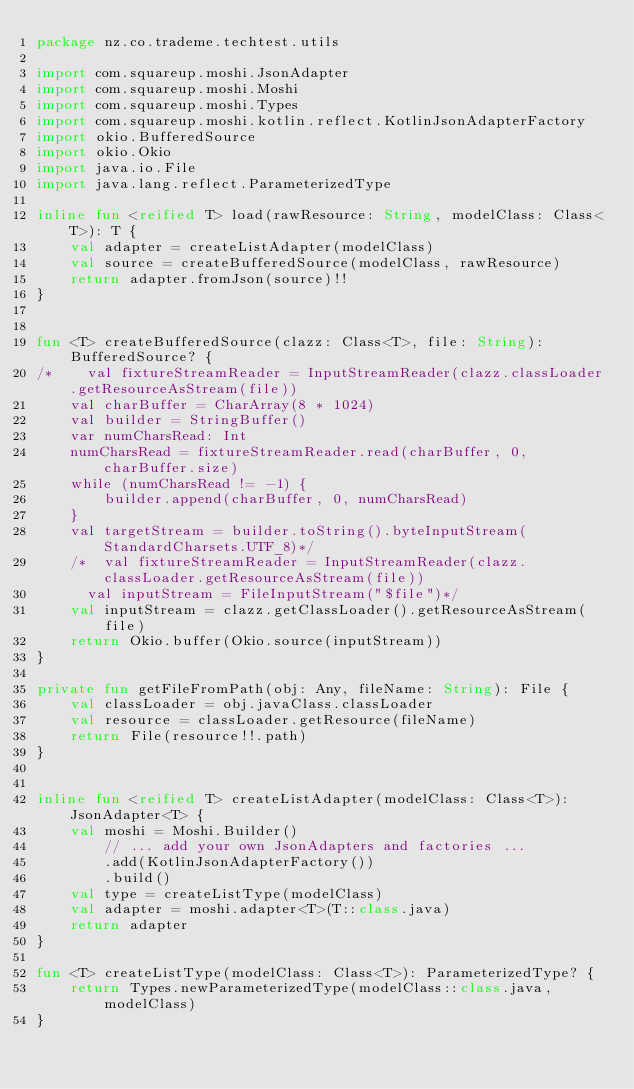Convert code to text. <code><loc_0><loc_0><loc_500><loc_500><_Kotlin_>package nz.co.trademe.techtest.utils

import com.squareup.moshi.JsonAdapter
import com.squareup.moshi.Moshi
import com.squareup.moshi.Types
import com.squareup.moshi.kotlin.reflect.KotlinJsonAdapterFactory
import okio.BufferedSource
import okio.Okio
import java.io.File
import java.lang.reflect.ParameterizedType

inline fun <reified T> load(rawResource: String, modelClass: Class<T>): T {
    val adapter = createListAdapter(modelClass)
    val source = createBufferedSource(modelClass, rawResource)
    return adapter.fromJson(source)!!
}


fun <T> createBufferedSource(clazz: Class<T>, file: String): BufferedSource? {
/*    val fixtureStreamReader = InputStreamReader(clazz.classLoader.getResourceAsStream(file))
    val charBuffer = CharArray(8 * 1024)
    val builder = StringBuffer()
    var numCharsRead: Int
    numCharsRead = fixtureStreamReader.read(charBuffer, 0, charBuffer.size)
    while (numCharsRead != -1) {
        builder.append(charBuffer, 0, numCharsRead)
    }
    val targetStream = builder.toString().byteInputStream(StandardCharsets.UTF_8)*/
    /*  val fixtureStreamReader = InputStreamReader(clazz.classLoader.getResourceAsStream(file))
      val inputStream = FileInputStream("$file")*/
    val inputStream = clazz.getClassLoader().getResourceAsStream(file)
    return Okio.buffer(Okio.source(inputStream))
}

private fun getFileFromPath(obj: Any, fileName: String): File {
    val classLoader = obj.javaClass.classLoader
    val resource = classLoader.getResource(fileName)
    return File(resource!!.path)
}


inline fun <reified T> createListAdapter(modelClass: Class<T>): JsonAdapter<T> {
    val moshi = Moshi.Builder()
        // ... add your own JsonAdapters and factories ...
        .add(KotlinJsonAdapterFactory())
        .build()
    val type = createListType(modelClass)
    val adapter = moshi.adapter<T>(T::class.java)
    return adapter
}

fun <T> createListType(modelClass: Class<T>): ParameterizedType? {
    return Types.newParameterizedType(modelClass::class.java, modelClass)
}
</code> 